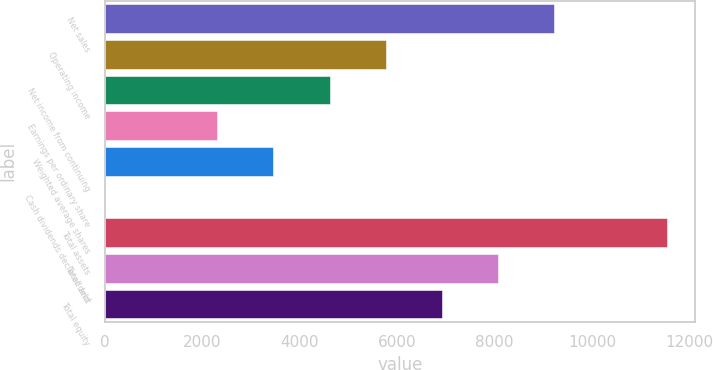Convert chart. <chart><loc_0><loc_0><loc_500><loc_500><bar_chart><fcel>Net sales<fcel>Operating income<fcel>Net income from continuing<fcel>Earnings per ordinary share<fcel>Weighted average shares<fcel>Cash dividends declared and<fcel>Total assets<fcel>Total debt<fcel>Total equity<nl><fcel>9227.94<fcel>5767.59<fcel>4614.14<fcel>2307.24<fcel>3460.69<fcel>0.34<fcel>11534.8<fcel>8074.49<fcel>6921.04<nl></chart> 